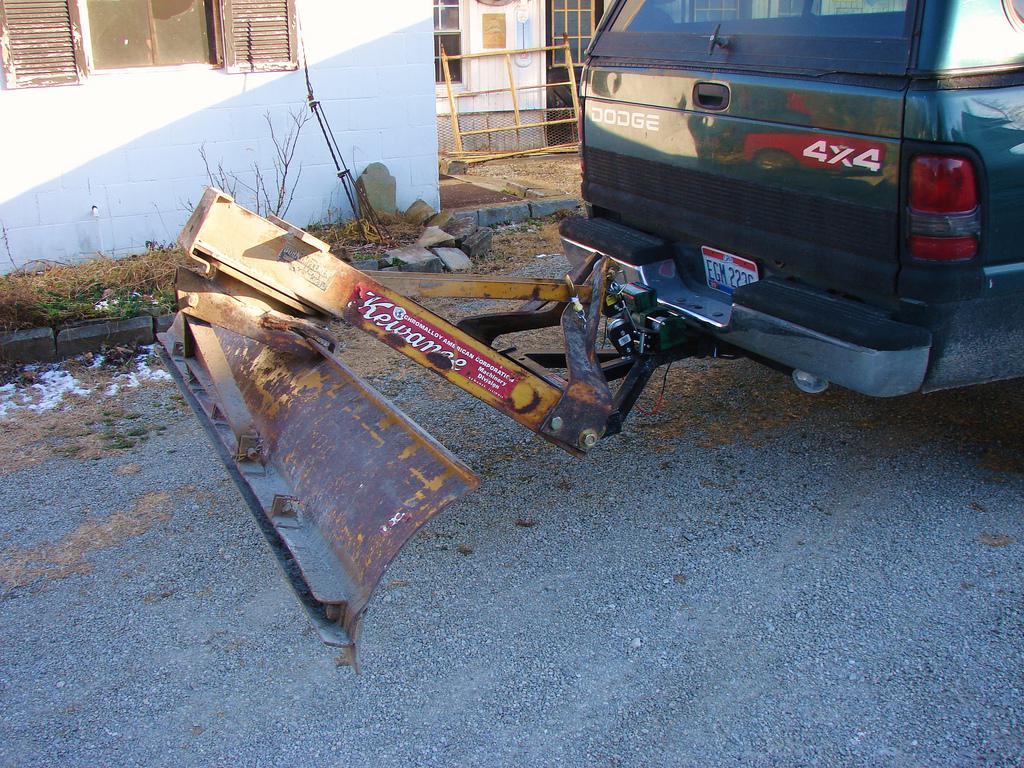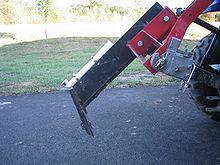The first image is the image on the left, the second image is the image on the right. For the images shown, is this caption "In one image, a pickup truck with rear mounted snow blade is on a snow covered street." true? Answer yes or no. No. The first image is the image on the left, the second image is the image on the right. Given the left and right images, does the statement "An image shows a dark pickup truck pulling a plow on a snowy street." hold true? Answer yes or no. No. 